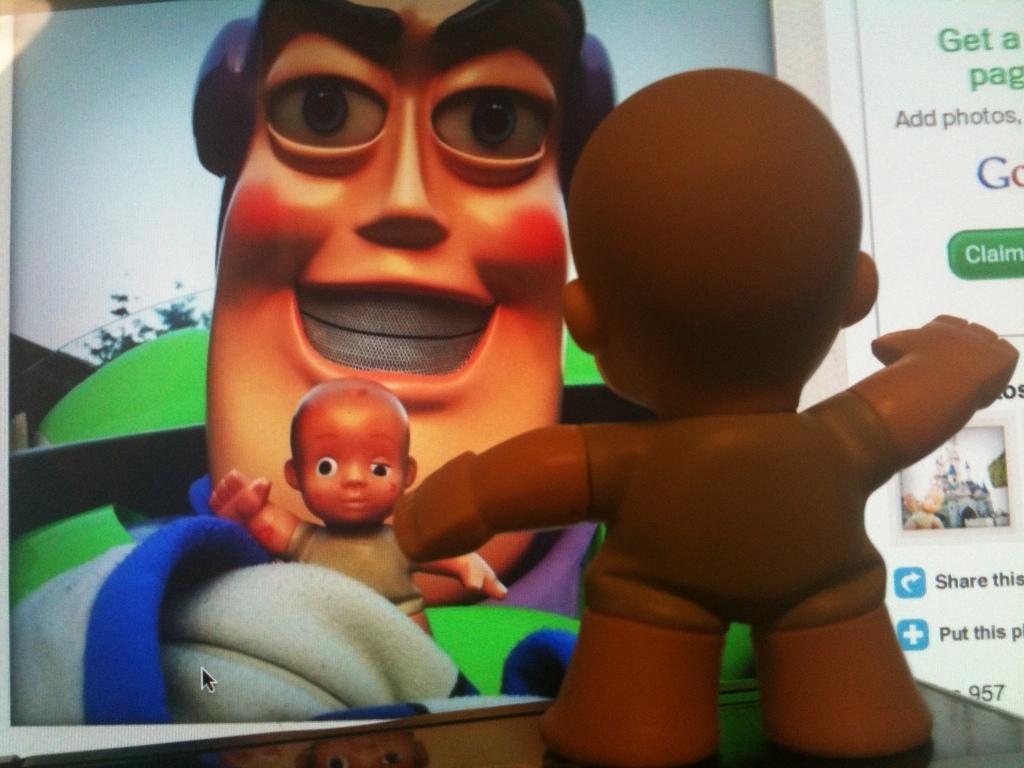Could you give a brief overview of what you see in this image? In the image we can see a toy and there is a poster, in the poster we can see there are two toys, tree and a sky. 